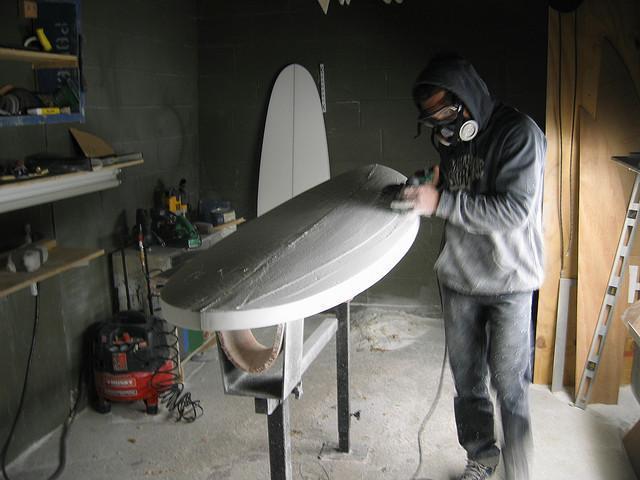How many surfboards can you see?
Give a very brief answer. 2. 